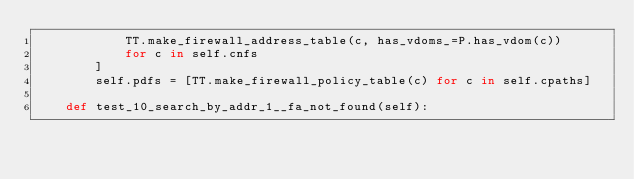Convert code to text. <code><loc_0><loc_0><loc_500><loc_500><_Python_>            TT.make_firewall_address_table(c, has_vdoms_=P.has_vdom(c))
            for c in self.cnfs
        ]
        self.pdfs = [TT.make_firewall_policy_table(c) for c in self.cpaths]

    def test_10_search_by_addr_1__fa_not_found(self):</code> 